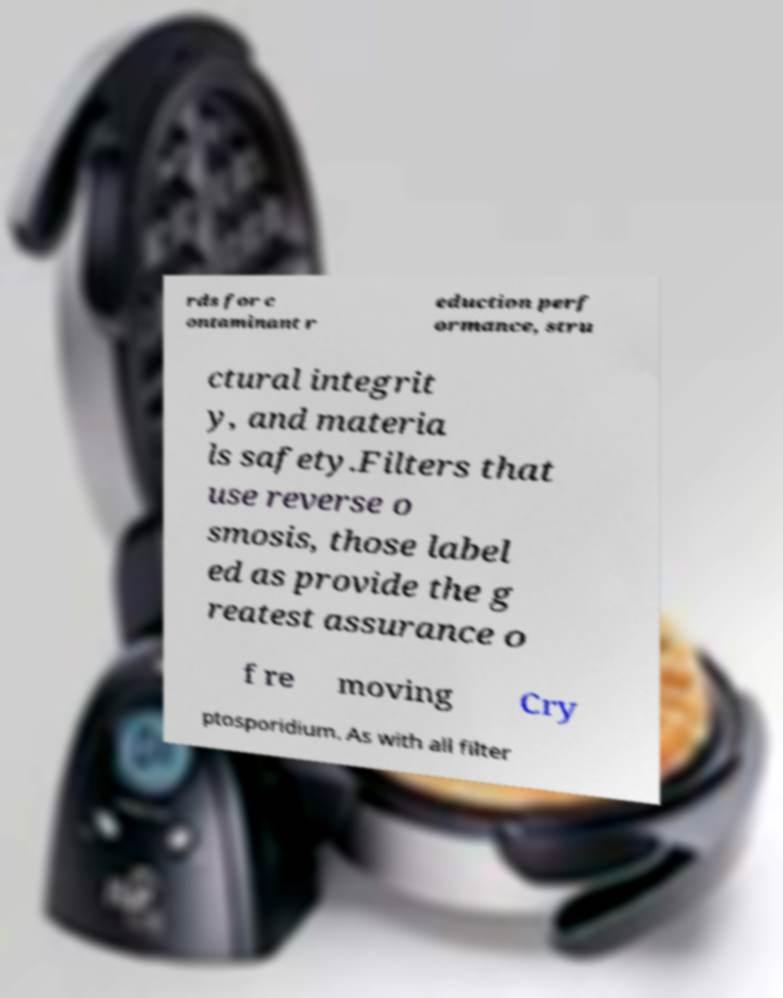Please identify and transcribe the text found in this image. rds for c ontaminant r eduction perf ormance, stru ctural integrit y, and materia ls safety.Filters that use reverse o smosis, those label ed as provide the g reatest assurance o f re moving Cry ptosporidium. As with all filter 